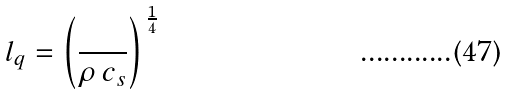Convert formula to latex. <formula><loc_0><loc_0><loc_500><loc_500>l _ { q } = \left ( \frac { } { \rho \, c _ { s } } \right ) ^ { \, \frac { 1 } { 4 } }</formula> 